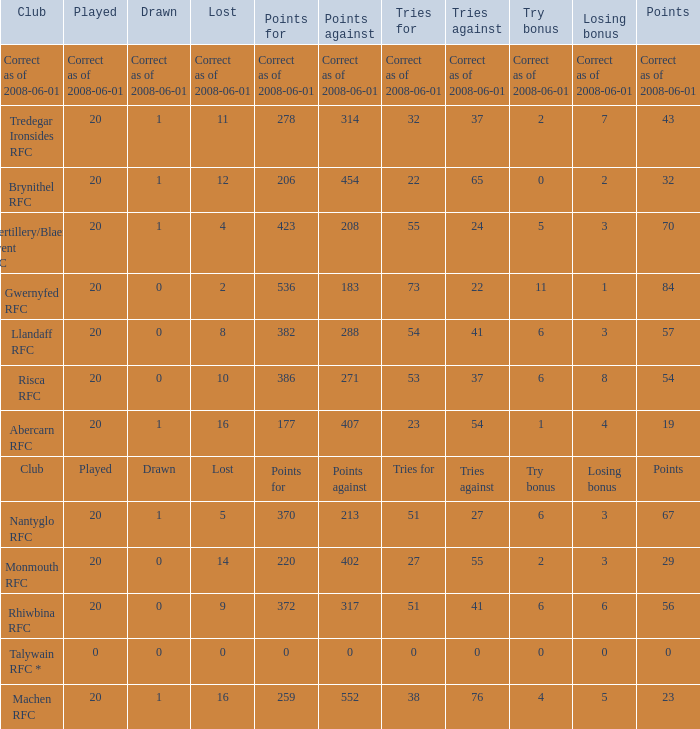What was the tries against when they had 32 tries for? 37.0. 